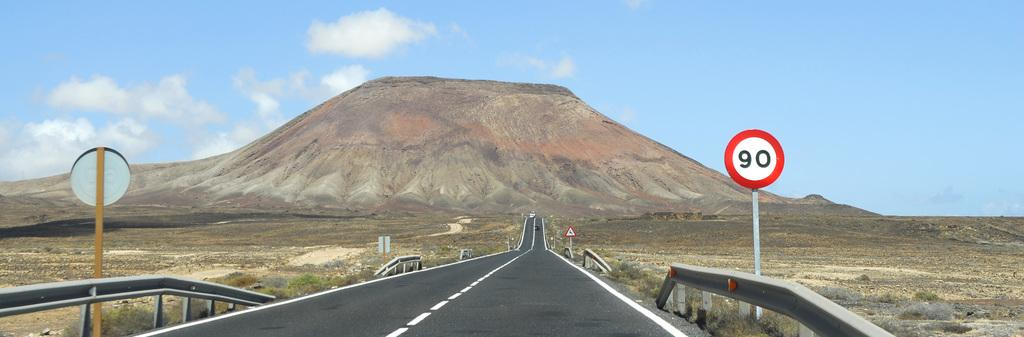<image>
Summarize the visual content of the image. A panoramic landscape photo of a highway with a 90 km/h speed limit leading up to a butte. 